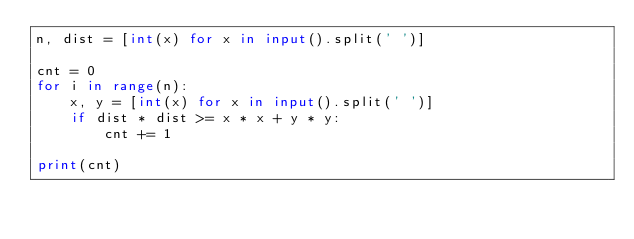<code> <loc_0><loc_0><loc_500><loc_500><_Python_>n, dist = [int(x) for x in input().split(' ')]

cnt = 0
for i in range(n):
    x, y = [int(x) for x in input().split(' ')]
    if dist * dist >= x * x + y * y:
        cnt += 1

print(cnt)</code> 